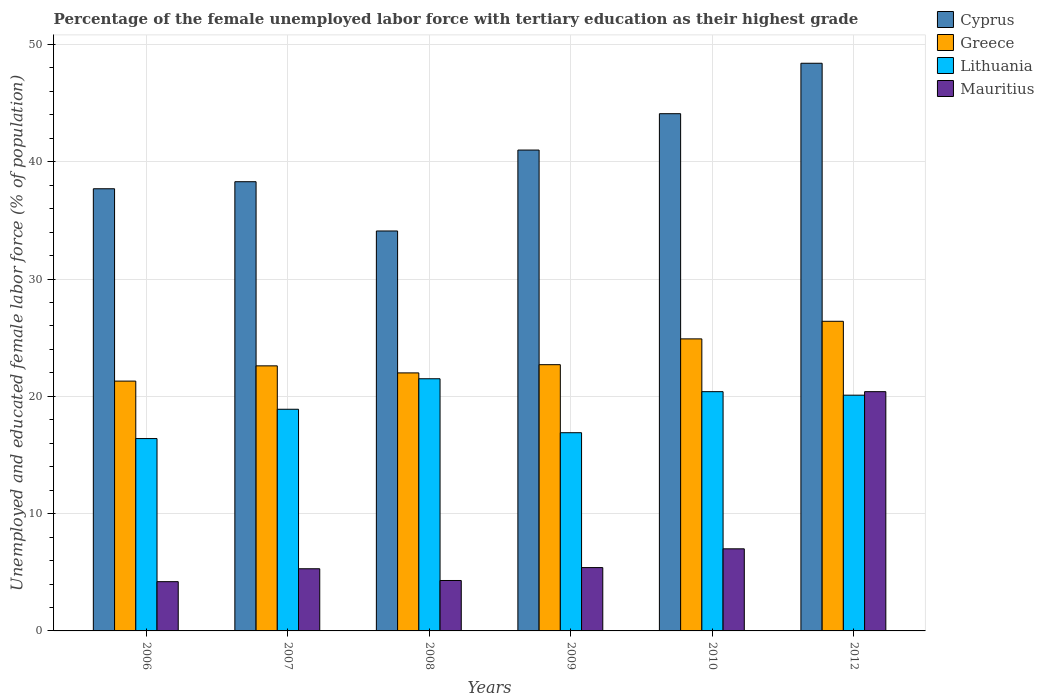How many different coloured bars are there?
Your response must be concise. 4. How many groups of bars are there?
Offer a terse response. 6. Are the number of bars per tick equal to the number of legend labels?
Ensure brevity in your answer.  Yes. Are the number of bars on each tick of the X-axis equal?
Offer a terse response. Yes. What is the label of the 4th group of bars from the left?
Your answer should be very brief. 2009. What is the percentage of the unemployed female labor force with tertiary education in Mauritius in 2009?
Offer a very short reply. 5.4. Across all years, what is the maximum percentage of the unemployed female labor force with tertiary education in Cyprus?
Ensure brevity in your answer.  48.4. Across all years, what is the minimum percentage of the unemployed female labor force with tertiary education in Cyprus?
Give a very brief answer. 34.1. What is the total percentage of the unemployed female labor force with tertiary education in Greece in the graph?
Offer a very short reply. 139.9. What is the difference between the percentage of the unemployed female labor force with tertiary education in Mauritius in 2008 and that in 2012?
Your answer should be compact. -16.1. What is the difference between the percentage of the unemployed female labor force with tertiary education in Mauritius in 2010 and the percentage of the unemployed female labor force with tertiary education in Lithuania in 2006?
Provide a succinct answer. -9.4. What is the average percentage of the unemployed female labor force with tertiary education in Cyprus per year?
Your answer should be very brief. 40.6. In the year 2010, what is the difference between the percentage of the unemployed female labor force with tertiary education in Lithuania and percentage of the unemployed female labor force with tertiary education in Greece?
Keep it short and to the point. -4.5. In how many years, is the percentage of the unemployed female labor force with tertiary education in Lithuania greater than 44 %?
Your answer should be very brief. 0. What is the ratio of the percentage of the unemployed female labor force with tertiary education in Greece in 2009 to that in 2012?
Give a very brief answer. 0.86. What is the difference between the highest and the second highest percentage of the unemployed female labor force with tertiary education in Cyprus?
Provide a short and direct response. 4.3. What is the difference between the highest and the lowest percentage of the unemployed female labor force with tertiary education in Mauritius?
Your response must be concise. 16.2. Is the sum of the percentage of the unemployed female labor force with tertiary education in Greece in 2009 and 2010 greater than the maximum percentage of the unemployed female labor force with tertiary education in Mauritius across all years?
Keep it short and to the point. Yes. Is it the case that in every year, the sum of the percentage of the unemployed female labor force with tertiary education in Lithuania and percentage of the unemployed female labor force with tertiary education in Mauritius is greater than the sum of percentage of the unemployed female labor force with tertiary education in Cyprus and percentage of the unemployed female labor force with tertiary education in Greece?
Provide a short and direct response. No. What does the 4th bar from the left in 2007 represents?
Provide a short and direct response. Mauritius. How many years are there in the graph?
Make the answer very short. 6. Are the values on the major ticks of Y-axis written in scientific E-notation?
Offer a very short reply. No. Does the graph contain any zero values?
Provide a succinct answer. No. Does the graph contain grids?
Offer a very short reply. Yes. How are the legend labels stacked?
Your answer should be compact. Vertical. What is the title of the graph?
Make the answer very short. Percentage of the female unemployed labor force with tertiary education as their highest grade. What is the label or title of the Y-axis?
Your answer should be very brief. Unemployed and educated female labor force (% of population). What is the Unemployed and educated female labor force (% of population) in Cyprus in 2006?
Provide a short and direct response. 37.7. What is the Unemployed and educated female labor force (% of population) in Greece in 2006?
Your answer should be compact. 21.3. What is the Unemployed and educated female labor force (% of population) of Lithuania in 2006?
Your answer should be very brief. 16.4. What is the Unemployed and educated female labor force (% of population) in Mauritius in 2006?
Your answer should be compact. 4.2. What is the Unemployed and educated female labor force (% of population) of Cyprus in 2007?
Provide a short and direct response. 38.3. What is the Unemployed and educated female labor force (% of population) in Greece in 2007?
Your response must be concise. 22.6. What is the Unemployed and educated female labor force (% of population) of Lithuania in 2007?
Your answer should be compact. 18.9. What is the Unemployed and educated female labor force (% of population) in Mauritius in 2007?
Provide a short and direct response. 5.3. What is the Unemployed and educated female labor force (% of population) of Cyprus in 2008?
Offer a very short reply. 34.1. What is the Unemployed and educated female labor force (% of population) of Mauritius in 2008?
Your answer should be very brief. 4.3. What is the Unemployed and educated female labor force (% of population) in Greece in 2009?
Make the answer very short. 22.7. What is the Unemployed and educated female labor force (% of population) of Lithuania in 2009?
Offer a terse response. 16.9. What is the Unemployed and educated female labor force (% of population) of Mauritius in 2009?
Your response must be concise. 5.4. What is the Unemployed and educated female labor force (% of population) of Cyprus in 2010?
Offer a very short reply. 44.1. What is the Unemployed and educated female labor force (% of population) in Greece in 2010?
Your answer should be very brief. 24.9. What is the Unemployed and educated female labor force (% of population) of Lithuania in 2010?
Provide a short and direct response. 20.4. What is the Unemployed and educated female labor force (% of population) in Cyprus in 2012?
Your answer should be compact. 48.4. What is the Unemployed and educated female labor force (% of population) in Greece in 2012?
Offer a terse response. 26.4. What is the Unemployed and educated female labor force (% of population) in Lithuania in 2012?
Offer a very short reply. 20.1. What is the Unemployed and educated female labor force (% of population) in Mauritius in 2012?
Provide a succinct answer. 20.4. Across all years, what is the maximum Unemployed and educated female labor force (% of population) of Cyprus?
Keep it short and to the point. 48.4. Across all years, what is the maximum Unemployed and educated female labor force (% of population) in Greece?
Keep it short and to the point. 26.4. Across all years, what is the maximum Unemployed and educated female labor force (% of population) of Lithuania?
Provide a short and direct response. 21.5. Across all years, what is the maximum Unemployed and educated female labor force (% of population) in Mauritius?
Give a very brief answer. 20.4. Across all years, what is the minimum Unemployed and educated female labor force (% of population) in Cyprus?
Provide a short and direct response. 34.1. Across all years, what is the minimum Unemployed and educated female labor force (% of population) of Greece?
Give a very brief answer. 21.3. Across all years, what is the minimum Unemployed and educated female labor force (% of population) in Lithuania?
Give a very brief answer. 16.4. Across all years, what is the minimum Unemployed and educated female labor force (% of population) of Mauritius?
Offer a very short reply. 4.2. What is the total Unemployed and educated female labor force (% of population) of Cyprus in the graph?
Offer a very short reply. 243.6. What is the total Unemployed and educated female labor force (% of population) in Greece in the graph?
Make the answer very short. 139.9. What is the total Unemployed and educated female labor force (% of population) in Lithuania in the graph?
Provide a short and direct response. 114.2. What is the total Unemployed and educated female labor force (% of population) in Mauritius in the graph?
Provide a short and direct response. 46.6. What is the difference between the Unemployed and educated female labor force (% of population) in Greece in 2006 and that in 2007?
Your answer should be compact. -1.3. What is the difference between the Unemployed and educated female labor force (% of population) of Greece in 2006 and that in 2008?
Your answer should be compact. -0.7. What is the difference between the Unemployed and educated female labor force (% of population) of Cyprus in 2006 and that in 2010?
Your answer should be compact. -6.4. What is the difference between the Unemployed and educated female labor force (% of population) in Greece in 2006 and that in 2010?
Give a very brief answer. -3.6. What is the difference between the Unemployed and educated female labor force (% of population) in Lithuania in 2006 and that in 2010?
Give a very brief answer. -4. What is the difference between the Unemployed and educated female labor force (% of population) of Mauritius in 2006 and that in 2010?
Offer a terse response. -2.8. What is the difference between the Unemployed and educated female labor force (% of population) of Cyprus in 2006 and that in 2012?
Your response must be concise. -10.7. What is the difference between the Unemployed and educated female labor force (% of population) of Lithuania in 2006 and that in 2012?
Keep it short and to the point. -3.7. What is the difference between the Unemployed and educated female labor force (% of population) of Mauritius in 2006 and that in 2012?
Keep it short and to the point. -16.2. What is the difference between the Unemployed and educated female labor force (% of population) in Greece in 2007 and that in 2008?
Offer a very short reply. 0.6. What is the difference between the Unemployed and educated female labor force (% of population) of Greece in 2007 and that in 2009?
Make the answer very short. -0.1. What is the difference between the Unemployed and educated female labor force (% of population) of Lithuania in 2007 and that in 2009?
Your answer should be compact. 2. What is the difference between the Unemployed and educated female labor force (% of population) in Mauritius in 2007 and that in 2009?
Make the answer very short. -0.1. What is the difference between the Unemployed and educated female labor force (% of population) of Mauritius in 2007 and that in 2010?
Your answer should be compact. -1.7. What is the difference between the Unemployed and educated female labor force (% of population) of Lithuania in 2007 and that in 2012?
Offer a terse response. -1.2. What is the difference between the Unemployed and educated female labor force (% of population) in Mauritius in 2007 and that in 2012?
Keep it short and to the point. -15.1. What is the difference between the Unemployed and educated female labor force (% of population) in Cyprus in 2008 and that in 2009?
Your response must be concise. -6.9. What is the difference between the Unemployed and educated female labor force (% of population) in Greece in 2008 and that in 2009?
Offer a terse response. -0.7. What is the difference between the Unemployed and educated female labor force (% of population) of Mauritius in 2008 and that in 2009?
Offer a very short reply. -1.1. What is the difference between the Unemployed and educated female labor force (% of population) of Cyprus in 2008 and that in 2012?
Your answer should be compact. -14.3. What is the difference between the Unemployed and educated female labor force (% of population) in Lithuania in 2008 and that in 2012?
Your answer should be very brief. 1.4. What is the difference between the Unemployed and educated female labor force (% of population) of Mauritius in 2008 and that in 2012?
Your answer should be compact. -16.1. What is the difference between the Unemployed and educated female labor force (% of population) in Cyprus in 2009 and that in 2010?
Ensure brevity in your answer.  -3.1. What is the difference between the Unemployed and educated female labor force (% of population) of Lithuania in 2009 and that in 2010?
Your answer should be compact. -3.5. What is the difference between the Unemployed and educated female labor force (% of population) of Lithuania in 2009 and that in 2012?
Your response must be concise. -3.2. What is the difference between the Unemployed and educated female labor force (% of population) of Mauritius in 2009 and that in 2012?
Provide a succinct answer. -15. What is the difference between the Unemployed and educated female labor force (% of population) in Lithuania in 2010 and that in 2012?
Keep it short and to the point. 0.3. What is the difference between the Unemployed and educated female labor force (% of population) in Mauritius in 2010 and that in 2012?
Your answer should be very brief. -13.4. What is the difference between the Unemployed and educated female labor force (% of population) in Cyprus in 2006 and the Unemployed and educated female labor force (% of population) in Lithuania in 2007?
Your answer should be compact. 18.8. What is the difference between the Unemployed and educated female labor force (% of population) of Cyprus in 2006 and the Unemployed and educated female labor force (% of population) of Mauritius in 2007?
Your answer should be very brief. 32.4. What is the difference between the Unemployed and educated female labor force (% of population) of Greece in 2006 and the Unemployed and educated female labor force (% of population) of Lithuania in 2007?
Make the answer very short. 2.4. What is the difference between the Unemployed and educated female labor force (% of population) in Greece in 2006 and the Unemployed and educated female labor force (% of population) in Mauritius in 2007?
Offer a terse response. 16. What is the difference between the Unemployed and educated female labor force (% of population) of Cyprus in 2006 and the Unemployed and educated female labor force (% of population) of Mauritius in 2008?
Make the answer very short. 33.4. What is the difference between the Unemployed and educated female labor force (% of population) in Cyprus in 2006 and the Unemployed and educated female labor force (% of population) in Lithuania in 2009?
Provide a succinct answer. 20.8. What is the difference between the Unemployed and educated female labor force (% of population) in Cyprus in 2006 and the Unemployed and educated female labor force (% of population) in Mauritius in 2009?
Make the answer very short. 32.3. What is the difference between the Unemployed and educated female labor force (% of population) in Cyprus in 2006 and the Unemployed and educated female labor force (% of population) in Greece in 2010?
Your response must be concise. 12.8. What is the difference between the Unemployed and educated female labor force (% of population) of Cyprus in 2006 and the Unemployed and educated female labor force (% of population) of Lithuania in 2010?
Ensure brevity in your answer.  17.3. What is the difference between the Unemployed and educated female labor force (% of population) in Cyprus in 2006 and the Unemployed and educated female labor force (% of population) in Mauritius in 2010?
Offer a terse response. 30.7. What is the difference between the Unemployed and educated female labor force (% of population) in Lithuania in 2006 and the Unemployed and educated female labor force (% of population) in Mauritius in 2010?
Ensure brevity in your answer.  9.4. What is the difference between the Unemployed and educated female labor force (% of population) of Cyprus in 2006 and the Unemployed and educated female labor force (% of population) of Lithuania in 2012?
Your answer should be compact. 17.6. What is the difference between the Unemployed and educated female labor force (% of population) in Cyprus in 2006 and the Unemployed and educated female labor force (% of population) in Mauritius in 2012?
Offer a terse response. 17.3. What is the difference between the Unemployed and educated female labor force (% of population) of Lithuania in 2006 and the Unemployed and educated female labor force (% of population) of Mauritius in 2012?
Offer a very short reply. -4. What is the difference between the Unemployed and educated female labor force (% of population) in Cyprus in 2007 and the Unemployed and educated female labor force (% of population) in Greece in 2008?
Provide a succinct answer. 16.3. What is the difference between the Unemployed and educated female labor force (% of population) of Cyprus in 2007 and the Unemployed and educated female labor force (% of population) of Lithuania in 2008?
Keep it short and to the point. 16.8. What is the difference between the Unemployed and educated female labor force (% of population) of Cyprus in 2007 and the Unemployed and educated female labor force (% of population) of Mauritius in 2008?
Provide a short and direct response. 34. What is the difference between the Unemployed and educated female labor force (% of population) of Greece in 2007 and the Unemployed and educated female labor force (% of population) of Mauritius in 2008?
Make the answer very short. 18.3. What is the difference between the Unemployed and educated female labor force (% of population) in Cyprus in 2007 and the Unemployed and educated female labor force (% of population) in Lithuania in 2009?
Offer a very short reply. 21.4. What is the difference between the Unemployed and educated female labor force (% of population) of Cyprus in 2007 and the Unemployed and educated female labor force (% of population) of Mauritius in 2009?
Your answer should be very brief. 32.9. What is the difference between the Unemployed and educated female labor force (% of population) of Greece in 2007 and the Unemployed and educated female labor force (% of population) of Mauritius in 2009?
Ensure brevity in your answer.  17.2. What is the difference between the Unemployed and educated female labor force (% of population) of Lithuania in 2007 and the Unemployed and educated female labor force (% of population) of Mauritius in 2009?
Provide a short and direct response. 13.5. What is the difference between the Unemployed and educated female labor force (% of population) in Cyprus in 2007 and the Unemployed and educated female labor force (% of population) in Greece in 2010?
Your answer should be very brief. 13.4. What is the difference between the Unemployed and educated female labor force (% of population) in Cyprus in 2007 and the Unemployed and educated female labor force (% of population) in Lithuania in 2010?
Give a very brief answer. 17.9. What is the difference between the Unemployed and educated female labor force (% of population) of Cyprus in 2007 and the Unemployed and educated female labor force (% of population) of Mauritius in 2010?
Offer a very short reply. 31.3. What is the difference between the Unemployed and educated female labor force (% of population) in Greece in 2007 and the Unemployed and educated female labor force (% of population) in Lithuania in 2010?
Offer a very short reply. 2.2. What is the difference between the Unemployed and educated female labor force (% of population) in Greece in 2007 and the Unemployed and educated female labor force (% of population) in Mauritius in 2010?
Keep it short and to the point. 15.6. What is the difference between the Unemployed and educated female labor force (% of population) in Cyprus in 2007 and the Unemployed and educated female labor force (% of population) in Greece in 2012?
Ensure brevity in your answer.  11.9. What is the difference between the Unemployed and educated female labor force (% of population) of Cyprus in 2007 and the Unemployed and educated female labor force (% of population) of Lithuania in 2012?
Provide a succinct answer. 18.2. What is the difference between the Unemployed and educated female labor force (% of population) of Cyprus in 2007 and the Unemployed and educated female labor force (% of population) of Mauritius in 2012?
Keep it short and to the point. 17.9. What is the difference between the Unemployed and educated female labor force (% of population) in Greece in 2007 and the Unemployed and educated female labor force (% of population) in Lithuania in 2012?
Give a very brief answer. 2.5. What is the difference between the Unemployed and educated female labor force (% of population) in Lithuania in 2007 and the Unemployed and educated female labor force (% of population) in Mauritius in 2012?
Your answer should be compact. -1.5. What is the difference between the Unemployed and educated female labor force (% of population) in Cyprus in 2008 and the Unemployed and educated female labor force (% of population) in Lithuania in 2009?
Your answer should be compact. 17.2. What is the difference between the Unemployed and educated female labor force (% of population) of Cyprus in 2008 and the Unemployed and educated female labor force (% of population) of Mauritius in 2009?
Offer a very short reply. 28.7. What is the difference between the Unemployed and educated female labor force (% of population) in Greece in 2008 and the Unemployed and educated female labor force (% of population) in Lithuania in 2009?
Make the answer very short. 5.1. What is the difference between the Unemployed and educated female labor force (% of population) in Greece in 2008 and the Unemployed and educated female labor force (% of population) in Mauritius in 2009?
Your answer should be very brief. 16.6. What is the difference between the Unemployed and educated female labor force (% of population) in Lithuania in 2008 and the Unemployed and educated female labor force (% of population) in Mauritius in 2009?
Provide a short and direct response. 16.1. What is the difference between the Unemployed and educated female labor force (% of population) in Cyprus in 2008 and the Unemployed and educated female labor force (% of population) in Greece in 2010?
Provide a short and direct response. 9.2. What is the difference between the Unemployed and educated female labor force (% of population) of Cyprus in 2008 and the Unemployed and educated female labor force (% of population) of Lithuania in 2010?
Your response must be concise. 13.7. What is the difference between the Unemployed and educated female labor force (% of population) of Cyprus in 2008 and the Unemployed and educated female labor force (% of population) of Mauritius in 2010?
Provide a succinct answer. 27.1. What is the difference between the Unemployed and educated female labor force (% of population) of Greece in 2008 and the Unemployed and educated female labor force (% of population) of Lithuania in 2010?
Your answer should be compact. 1.6. What is the difference between the Unemployed and educated female labor force (% of population) of Greece in 2008 and the Unemployed and educated female labor force (% of population) of Mauritius in 2010?
Your response must be concise. 15. What is the difference between the Unemployed and educated female labor force (% of population) of Cyprus in 2008 and the Unemployed and educated female labor force (% of population) of Greece in 2012?
Make the answer very short. 7.7. What is the difference between the Unemployed and educated female labor force (% of population) in Cyprus in 2008 and the Unemployed and educated female labor force (% of population) in Lithuania in 2012?
Give a very brief answer. 14. What is the difference between the Unemployed and educated female labor force (% of population) of Cyprus in 2008 and the Unemployed and educated female labor force (% of population) of Mauritius in 2012?
Give a very brief answer. 13.7. What is the difference between the Unemployed and educated female labor force (% of population) in Greece in 2008 and the Unemployed and educated female labor force (% of population) in Mauritius in 2012?
Offer a terse response. 1.6. What is the difference between the Unemployed and educated female labor force (% of population) of Cyprus in 2009 and the Unemployed and educated female labor force (% of population) of Greece in 2010?
Keep it short and to the point. 16.1. What is the difference between the Unemployed and educated female labor force (% of population) of Cyprus in 2009 and the Unemployed and educated female labor force (% of population) of Lithuania in 2010?
Your answer should be compact. 20.6. What is the difference between the Unemployed and educated female labor force (% of population) in Cyprus in 2009 and the Unemployed and educated female labor force (% of population) in Mauritius in 2010?
Ensure brevity in your answer.  34. What is the difference between the Unemployed and educated female labor force (% of population) of Greece in 2009 and the Unemployed and educated female labor force (% of population) of Lithuania in 2010?
Provide a succinct answer. 2.3. What is the difference between the Unemployed and educated female labor force (% of population) in Greece in 2009 and the Unemployed and educated female labor force (% of population) in Mauritius in 2010?
Keep it short and to the point. 15.7. What is the difference between the Unemployed and educated female labor force (% of population) in Lithuania in 2009 and the Unemployed and educated female labor force (% of population) in Mauritius in 2010?
Give a very brief answer. 9.9. What is the difference between the Unemployed and educated female labor force (% of population) of Cyprus in 2009 and the Unemployed and educated female labor force (% of population) of Lithuania in 2012?
Offer a terse response. 20.9. What is the difference between the Unemployed and educated female labor force (% of population) in Cyprus in 2009 and the Unemployed and educated female labor force (% of population) in Mauritius in 2012?
Ensure brevity in your answer.  20.6. What is the difference between the Unemployed and educated female labor force (% of population) of Greece in 2009 and the Unemployed and educated female labor force (% of population) of Mauritius in 2012?
Offer a very short reply. 2.3. What is the difference between the Unemployed and educated female labor force (% of population) of Cyprus in 2010 and the Unemployed and educated female labor force (% of population) of Greece in 2012?
Your answer should be compact. 17.7. What is the difference between the Unemployed and educated female labor force (% of population) in Cyprus in 2010 and the Unemployed and educated female labor force (% of population) in Mauritius in 2012?
Keep it short and to the point. 23.7. What is the difference between the Unemployed and educated female labor force (% of population) in Greece in 2010 and the Unemployed and educated female labor force (% of population) in Lithuania in 2012?
Make the answer very short. 4.8. What is the difference between the Unemployed and educated female labor force (% of population) of Greece in 2010 and the Unemployed and educated female labor force (% of population) of Mauritius in 2012?
Your answer should be very brief. 4.5. What is the difference between the Unemployed and educated female labor force (% of population) in Lithuania in 2010 and the Unemployed and educated female labor force (% of population) in Mauritius in 2012?
Provide a succinct answer. 0. What is the average Unemployed and educated female labor force (% of population) of Cyprus per year?
Give a very brief answer. 40.6. What is the average Unemployed and educated female labor force (% of population) of Greece per year?
Ensure brevity in your answer.  23.32. What is the average Unemployed and educated female labor force (% of population) in Lithuania per year?
Provide a succinct answer. 19.03. What is the average Unemployed and educated female labor force (% of population) of Mauritius per year?
Make the answer very short. 7.77. In the year 2006, what is the difference between the Unemployed and educated female labor force (% of population) of Cyprus and Unemployed and educated female labor force (% of population) of Greece?
Your answer should be compact. 16.4. In the year 2006, what is the difference between the Unemployed and educated female labor force (% of population) of Cyprus and Unemployed and educated female labor force (% of population) of Lithuania?
Offer a terse response. 21.3. In the year 2006, what is the difference between the Unemployed and educated female labor force (% of population) in Cyprus and Unemployed and educated female labor force (% of population) in Mauritius?
Ensure brevity in your answer.  33.5. In the year 2006, what is the difference between the Unemployed and educated female labor force (% of population) of Lithuania and Unemployed and educated female labor force (% of population) of Mauritius?
Offer a terse response. 12.2. In the year 2007, what is the difference between the Unemployed and educated female labor force (% of population) of Cyprus and Unemployed and educated female labor force (% of population) of Greece?
Offer a terse response. 15.7. In the year 2007, what is the difference between the Unemployed and educated female labor force (% of population) of Greece and Unemployed and educated female labor force (% of population) of Lithuania?
Your response must be concise. 3.7. In the year 2007, what is the difference between the Unemployed and educated female labor force (% of population) of Greece and Unemployed and educated female labor force (% of population) of Mauritius?
Your answer should be very brief. 17.3. In the year 2008, what is the difference between the Unemployed and educated female labor force (% of population) in Cyprus and Unemployed and educated female labor force (% of population) in Mauritius?
Your answer should be very brief. 29.8. In the year 2008, what is the difference between the Unemployed and educated female labor force (% of population) of Greece and Unemployed and educated female labor force (% of population) of Mauritius?
Make the answer very short. 17.7. In the year 2009, what is the difference between the Unemployed and educated female labor force (% of population) of Cyprus and Unemployed and educated female labor force (% of population) of Greece?
Ensure brevity in your answer.  18.3. In the year 2009, what is the difference between the Unemployed and educated female labor force (% of population) in Cyprus and Unemployed and educated female labor force (% of population) in Lithuania?
Offer a terse response. 24.1. In the year 2009, what is the difference between the Unemployed and educated female labor force (% of population) of Cyprus and Unemployed and educated female labor force (% of population) of Mauritius?
Keep it short and to the point. 35.6. In the year 2009, what is the difference between the Unemployed and educated female labor force (% of population) of Greece and Unemployed and educated female labor force (% of population) of Lithuania?
Your answer should be very brief. 5.8. In the year 2009, what is the difference between the Unemployed and educated female labor force (% of population) of Greece and Unemployed and educated female labor force (% of population) of Mauritius?
Offer a terse response. 17.3. In the year 2009, what is the difference between the Unemployed and educated female labor force (% of population) in Lithuania and Unemployed and educated female labor force (% of population) in Mauritius?
Offer a terse response. 11.5. In the year 2010, what is the difference between the Unemployed and educated female labor force (% of population) of Cyprus and Unemployed and educated female labor force (% of population) of Lithuania?
Keep it short and to the point. 23.7. In the year 2010, what is the difference between the Unemployed and educated female labor force (% of population) of Cyprus and Unemployed and educated female labor force (% of population) of Mauritius?
Your answer should be very brief. 37.1. In the year 2012, what is the difference between the Unemployed and educated female labor force (% of population) in Cyprus and Unemployed and educated female labor force (% of population) in Greece?
Ensure brevity in your answer.  22. In the year 2012, what is the difference between the Unemployed and educated female labor force (% of population) in Cyprus and Unemployed and educated female labor force (% of population) in Lithuania?
Provide a short and direct response. 28.3. In the year 2012, what is the difference between the Unemployed and educated female labor force (% of population) of Greece and Unemployed and educated female labor force (% of population) of Lithuania?
Make the answer very short. 6.3. In the year 2012, what is the difference between the Unemployed and educated female labor force (% of population) of Lithuania and Unemployed and educated female labor force (% of population) of Mauritius?
Your answer should be compact. -0.3. What is the ratio of the Unemployed and educated female labor force (% of population) in Cyprus in 2006 to that in 2007?
Offer a terse response. 0.98. What is the ratio of the Unemployed and educated female labor force (% of population) in Greece in 2006 to that in 2007?
Keep it short and to the point. 0.94. What is the ratio of the Unemployed and educated female labor force (% of population) in Lithuania in 2006 to that in 2007?
Provide a succinct answer. 0.87. What is the ratio of the Unemployed and educated female labor force (% of population) of Mauritius in 2006 to that in 2007?
Your answer should be very brief. 0.79. What is the ratio of the Unemployed and educated female labor force (% of population) in Cyprus in 2006 to that in 2008?
Give a very brief answer. 1.11. What is the ratio of the Unemployed and educated female labor force (% of population) of Greece in 2006 to that in 2008?
Your response must be concise. 0.97. What is the ratio of the Unemployed and educated female labor force (% of population) of Lithuania in 2006 to that in 2008?
Your answer should be compact. 0.76. What is the ratio of the Unemployed and educated female labor force (% of population) of Mauritius in 2006 to that in 2008?
Offer a terse response. 0.98. What is the ratio of the Unemployed and educated female labor force (% of population) in Cyprus in 2006 to that in 2009?
Your answer should be compact. 0.92. What is the ratio of the Unemployed and educated female labor force (% of population) of Greece in 2006 to that in 2009?
Give a very brief answer. 0.94. What is the ratio of the Unemployed and educated female labor force (% of population) in Lithuania in 2006 to that in 2009?
Give a very brief answer. 0.97. What is the ratio of the Unemployed and educated female labor force (% of population) of Cyprus in 2006 to that in 2010?
Offer a terse response. 0.85. What is the ratio of the Unemployed and educated female labor force (% of population) in Greece in 2006 to that in 2010?
Provide a short and direct response. 0.86. What is the ratio of the Unemployed and educated female labor force (% of population) in Lithuania in 2006 to that in 2010?
Keep it short and to the point. 0.8. What is the ratio of the Unemployed and educated female labor force (% of population) in Mauritius in 2006 to that in 2010?
Keep it short and to the point. 0.6. What is the ratio of the Unemployed and educated female labor force (% of population) in Cyprus in 2006 to that in 2012?
Give a very brief answer. 0.78. What is the ratio of the Unemployed and educated female labor force (% of population) of Greece in 2006 to that in 2012?
Your answer should be very brief. 0.81. What is the ratio of the Unemployed and educated female labor force (% of population) in Lithuania in 2006 to that in 2012?
Your response must be concise. 0.82. What is the ratio of the Unemployed and educated female labor force (% of population) in Mauritius in 2006 to that in 2012?
Your answer should be very brief. 0.21. What is the ratio of the Unemployed and educated female labor force (% of population) of Cyprus in 2007 to that in 2008?
Offer a very short reply. 1.12. What is the ratio of the Unemployed and educated female labor force (% of population) in Greece in 2007 to that in 2008?
Offer a very short reply. 1.03. What is the ratio of the Unemployed and educated female labor force (% of population) in Lithuania in 2007 to that in 2008?
Your answer should be very brief. 0.88. What is the ratio of the Unemployed and educated female labor force (% of population) of Mauritius in 2007 to that in 2008?
Provide a succinct answer. 1.23. What is the ratio of the Unemployed and educated female labor force (% of population) in Cyprus in 2007 to that in 2009?
Give a very brief answer. 0.93. What is the ratio of the Unemployed and educated female labor force (% of population) in Lithuania in 2007 to that in 2009?
Offer a terse response. 1.12. What is the ratio of the Unemployed and educated female labor force (% of population) of Mauritius in 2007 to that in 2009?
Your answer should be compact. 0.98. What is the ratio of the Unemployed and educated female labor force (% of population) in Cyprus in 2007 to that in 2010?
Make the answer very short. 0.87. What is the ratio of the Unemployed and educated female labor force (% of population) of Greece in 2007 to that in 2010?
Provide a succinct answer. 0.91. What is the ratio of the Unemployed and educated female labor force (% of population) of Lithuania in 2007 to that in 2010?
Offer a terse response. 0.93. What is the ratio of the Unemployed and educated female labor force (% of population) of Mauritius in 2007 to that in 2010?
Give a very brief answer. 0.76. What is the ratio of the Unemployed and educated female labor force (% of population) in Cyprus in 2007 to that in 2012?
Make the answer very short. 0.79. What is the ratio of the Unemployed and educated female labor force (% of population) of Greece in 2007 to that in 2012?
Your answer should be very brief. 0.86. What is the ratio of the Unemployed and educated female labor force (% of population) of Lithuania in 2007 to that in 2012?
Your answer should be compact. 0.94. What is the ratio of the Unemployed and educated female labor force (% of population) of Mauritius in 2007 to that in 2012?
Your response must be concise. 0.26. What is the ratio of the Unemployed and educated female labor force (% of population) of Cyprus in 2008 to that in 2009?
Make the answer very short. 0.83. What is the ratio of the Unemployed and educated female labor force (% of population) of Greece in 2008 to that in 2009?
Provide a succinct answer. 0.97. What is the ratio of the Unemployed and educated female labor force (% of population) in Lithuania in 2008 to that in 2009?
Provide a short and direct response. 1.27. What is the ratio of the Unemployed and educated female labor force (% of population) of Mauritius in 2008 to that in 2009?
Offer a terse response. 0.8. What is the ratio of the Unemployed and educated female labor force (% of population) of Cyprus in 2008 to that in 2010?
Ensure brevity in your answer.  0.77. What is the ratio of the Unemployed and educated female labor force (% of population) of Greece in 2008 to that in 2010?
Give a very brief answer. 0.88. What is the ratio of the Unemployed and educated female labor force (% of population) of Lithuania in 2008 to that in 2010?
Give a very brief answer. 1.05. What is the ratio of the Unemployed and educated female labor force (% of population) of Mauritius in 2008 to that in 2010?
Keep it short and to the point. 0.61. What is the ratio of the Unemployed and educated female labor force (% of population) of Cyprus in 2008 to that in 2012?
Your answer should be compact. 0.7. What is the ratio of the Unemployed and educated female labor force (% of population) in Greece in 2008 to that in 2012?
Make the answer very short. 0.83. What is the ratio of the Unemployed and educated female labor force (% of population) in Lithuania in 2008 to that in 2012?
Ensure brevity in your answer.  1.07. What is the ratio of the Unemployed and educated female labor force (% of population) in Mauritius in 2008 to that in 2012?
Your response must be concise. 0.21. What is the ratio of the Unemployed and educated female labor force (% of population) in Cyprus in 2009 to that in 2010?
Provide a succinct answer. 0.93. What is the ratio of the Unemployed and educated female labor force (% of population) in Greece in 2009 to that in 2010?
Provide a short and direct response. 0.91. What is the ratio of the Unemployed and educated female labor force (% of population) of Lithuania in 2009 to that in 2010?
Provide a short and direct response. 0.83. What is the ratio of the Unemployed and educated female labor force (% of population) of Mauritius in 2009 to that in 2010?
Keep it short and to the point. 0.77. What is the ratio of the Unemployed and educated female labor force (% of population) in Cyprus in 2009 to that in 2012?
Give a very brief answer. 0.85. What is the ratio of the Unemployed and educated female labor force (% of population) of Greece in 2009 to that in 2012?
Offer a very short reply. 0.86. What is the ratio of the Unemployed and educated female labor force (% of population) in Lithuania in 2009 to that in 2012?
Your response must be concise. 0.84. What is the ratio of the Unemployed and educated female labor force (% of population) of Mauritius in 2009 to that in 2012?
Offer a terse response. 0.26. What is the ratio of the Unemployed and educated female labor force (% of population) in Cyprus in 2010 to that in 2012?
Your answer should be very brief. 0.91. What is the ratio of the Unemployed and educated female labor force (% of population) of Greece in 2010 to that in 2012?
Offer a very short reply. 0.94. What is the ratio of the Unemployed and educated female labor force (% of population) in Lithuania in 2010 to that in 2012?
Your response must be concise. 1.01. What is the ratio of the Unemployed and educated female labor force (% of population) of Mauritius in 2010 to that in 2012?
Make the answer very short. 0.34. What is the difference between the highest and the second highest Unemployed and educated female labor force (% of population) in Lithuania?
Make the answer very short. 1.1. 